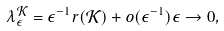Convert formula to latex. <formula><loc_0><loc_0><loc_500><loc_500>\lambda _ { \epsilon } ^ { \mathcal { K } } = \epsilon ^ { - 1 } r ( \mathcal { K } ) + o ( \epsilon ^ { - 1 } ) \epsilon \rightarrow 0 ,</formula> 